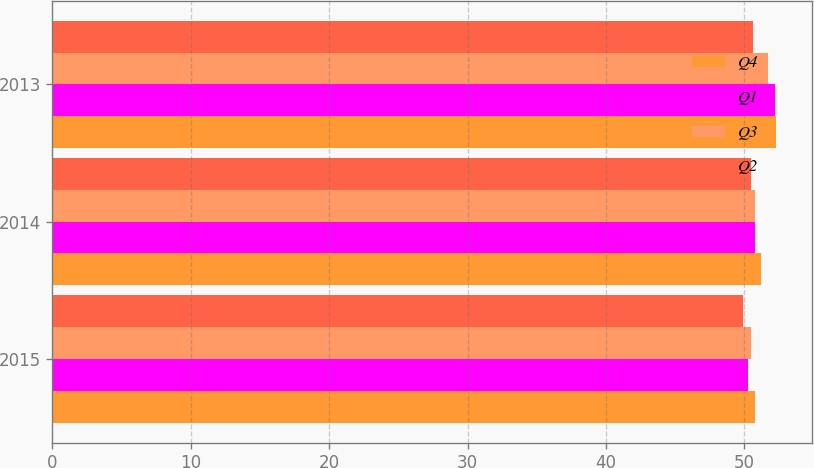<chart> <loc_0><loc_0><loc_500><loc_500><stacked_bar_chart><ecel><fcel>2015<fcel>2014<fcel>2013<nl><fcel>Q4<fcel>50.8<fcel>51.2<fcel>52.3<nl><fcel>Q1<fcel>50.3<fcel>50.8<fcel>52.2<nl><fcel>Q3<fcel>50.5<fcel>50.8<fcel>51.7<nl><fcel>Q2<fcel>49.9<fcel>50.5<fcel>50.6<nl></chart> 